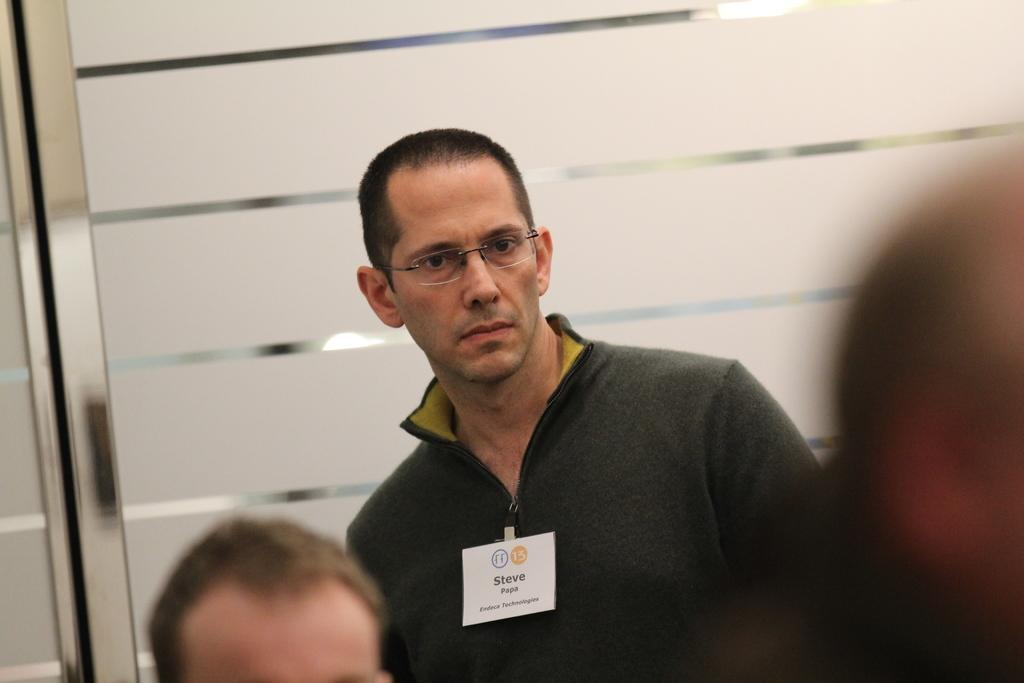What can be seen in the image related to a person? There is a person in the image, and the person is wearing spectacles. What is the person doing in the image? The person is standing in the image. Can you describe the head of the person in the image? Yes, there is a head of a person visible in the image. What type of objects are made of glass in the image? There are glass objects in the image. What can be seen through the glass objects? Lights are visible through the glass objects. What type of feather can be seen floating in the air in the image? There is no feather visible in the image; it only features a person, spectacles, standing position, head, glass objects, and lights. 